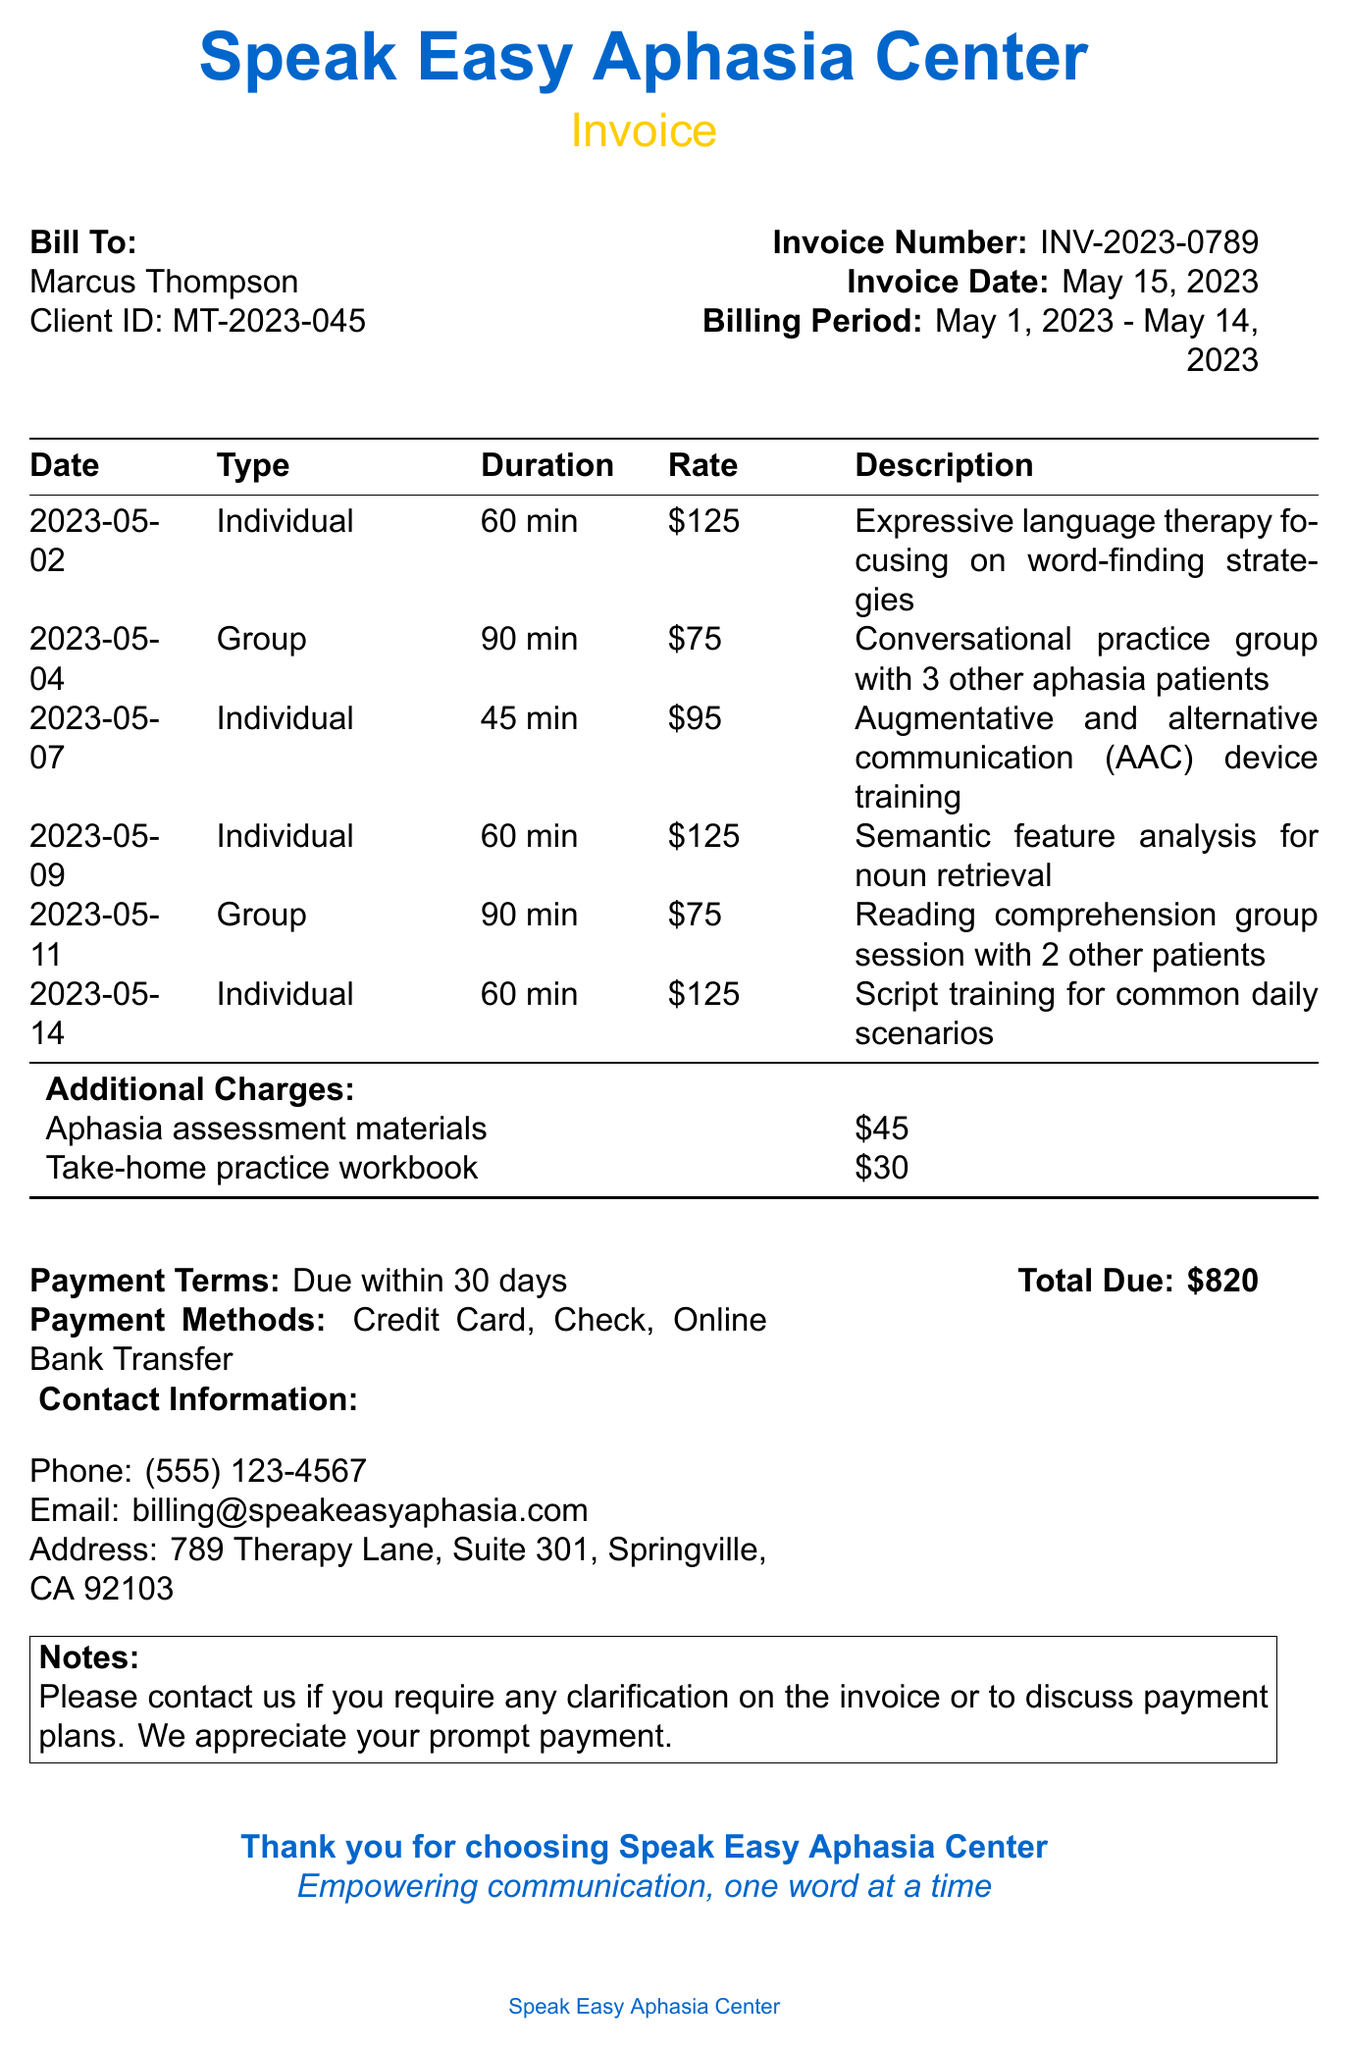What is the name of the clinic? The clinic's name is listed at the top of the invoice.
Answer: Speak Easy Aphasia Center Who is the therapist for the sessions? The therapist's name is mentioned on the invoice.
Answer: Dr. Emily Chen What is the total due amount? The total due is provided at the bottom of the document.
Answer: $820 What is the invoice date? The invoice date is specified in the document.
Answer: May 15, 2023 How many individual sessions were conducted? The document lists the types of sessions, and individual sessions can be counted from that.
Answer: 4 What type of therapies were included in the group sessions? The document describes the focus of the group therapy sessions.
Answer: Conversational practice and reading comprehension What is the billing period for this invoice? The billing period is provided in the invoice details.
Answer: May 1, 2023 - May 14, 2023 What are the payment terms stated in the invoice? The payment terms are noted in the invoice information section.
Answer: Due within 30 days What additional charge is for the take-home practice workbook? The additional charge for the workbook is specified among the extra charges.
Answer: $30 